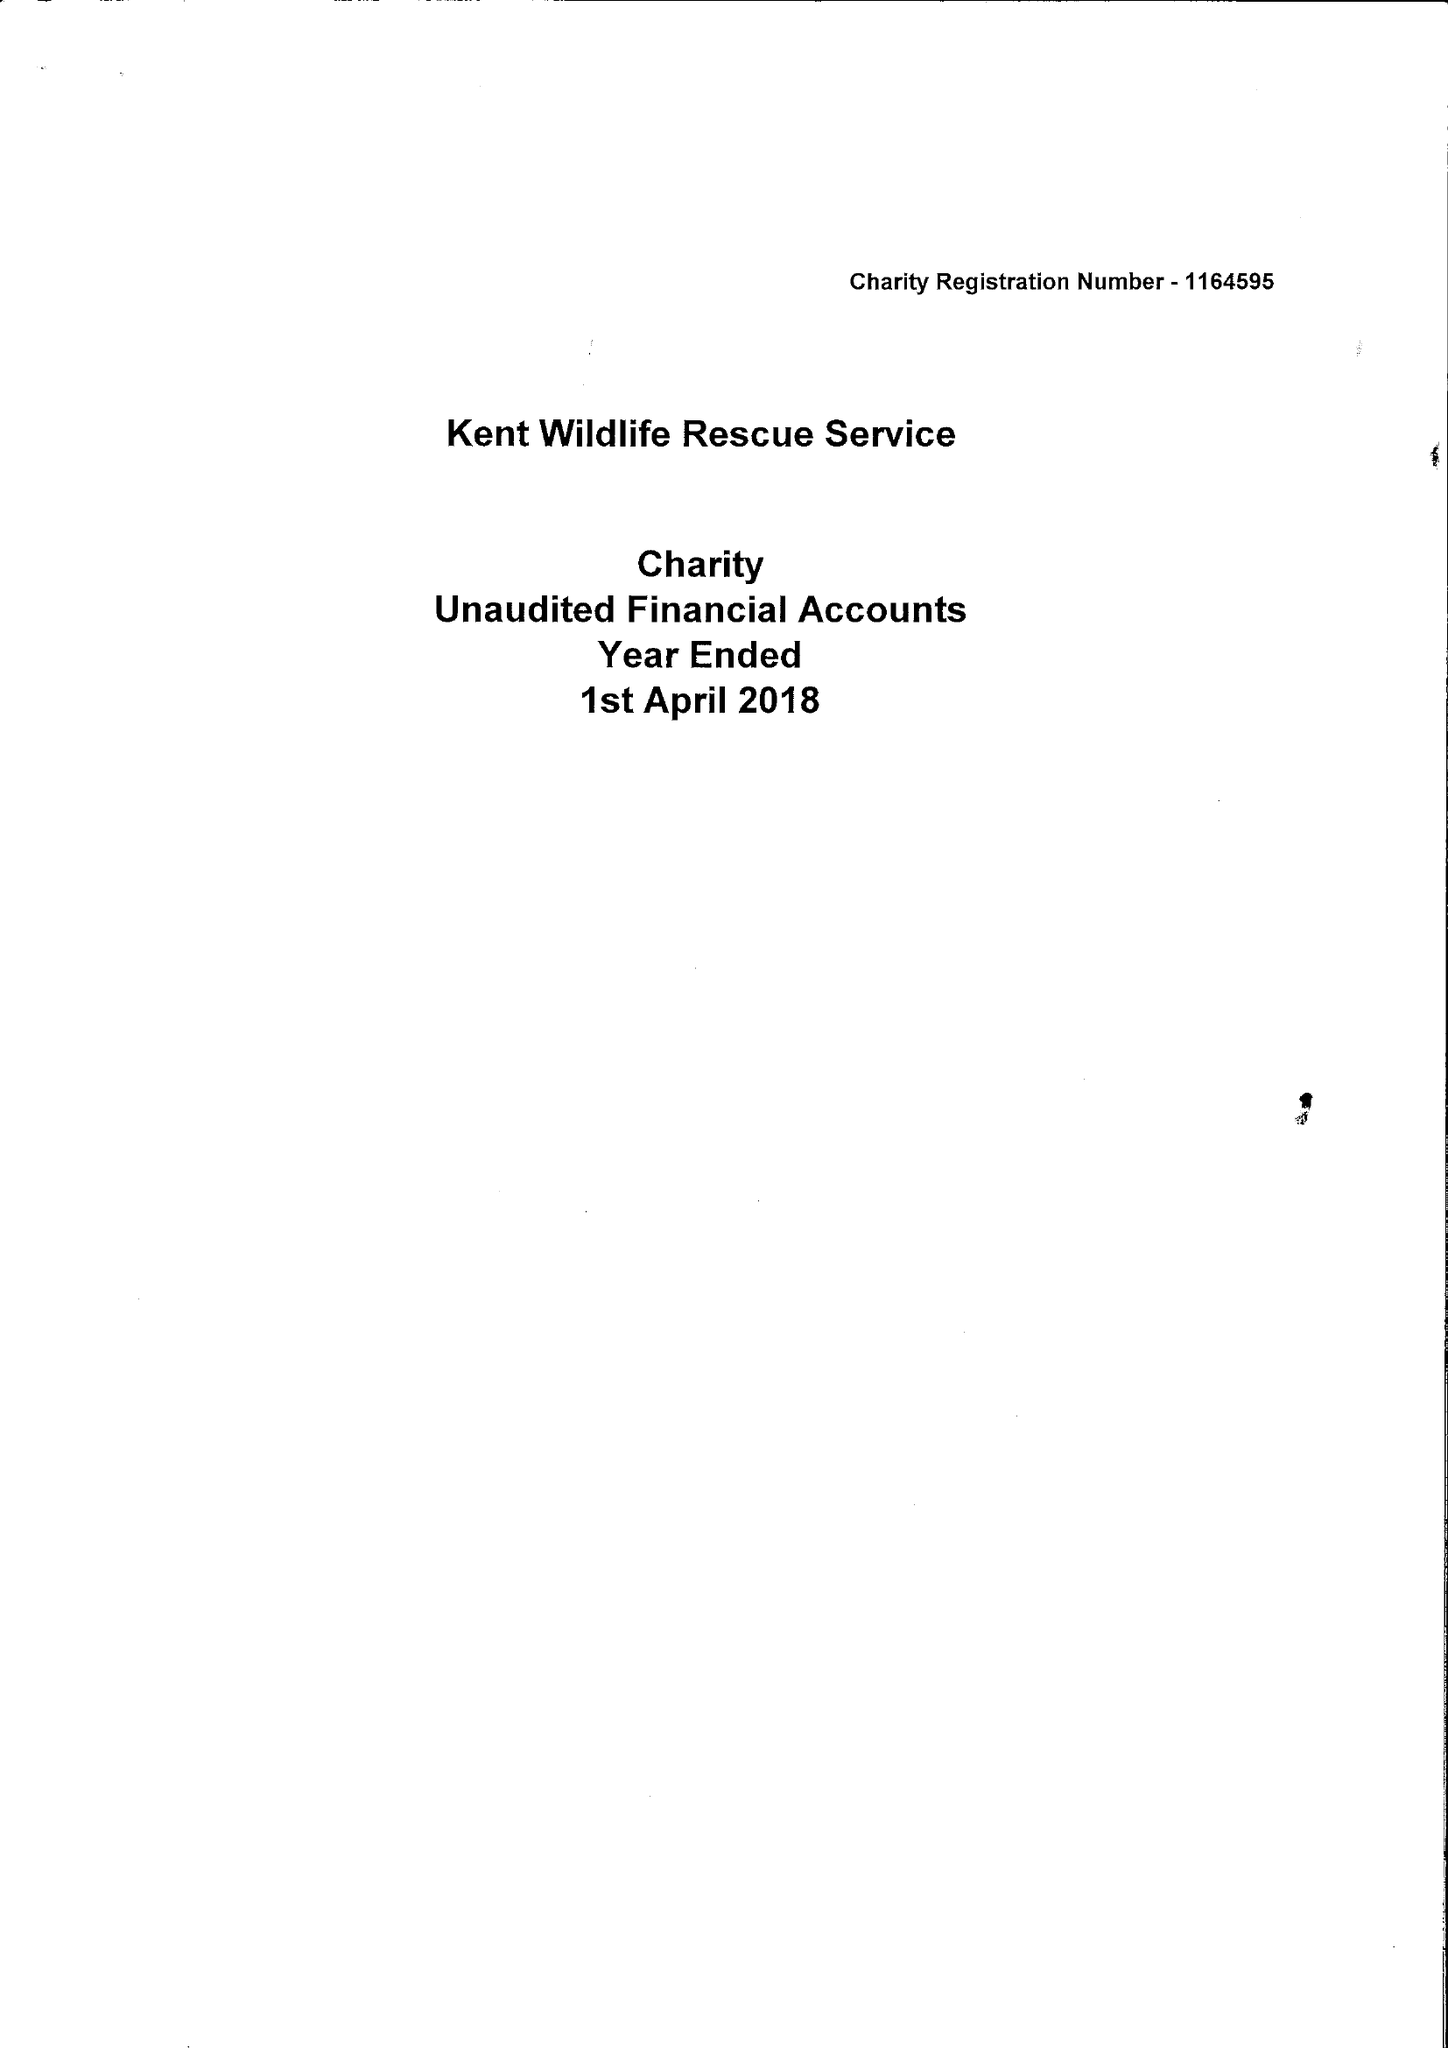What is the value for the address__postcode?
Answer the question using a single word or phrase. ME12 1YF 